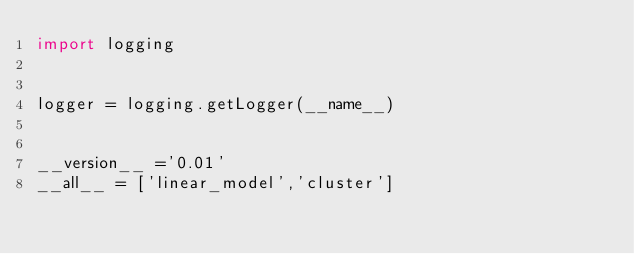Convert code to text. <code><loc_0><loc_0><loc_500><loc_500><_Python_>import logging


logger = logging.getLogger(__name__)


__version__ ='0.01' 
__all__ = ['linear_model','cluster']
</code> 